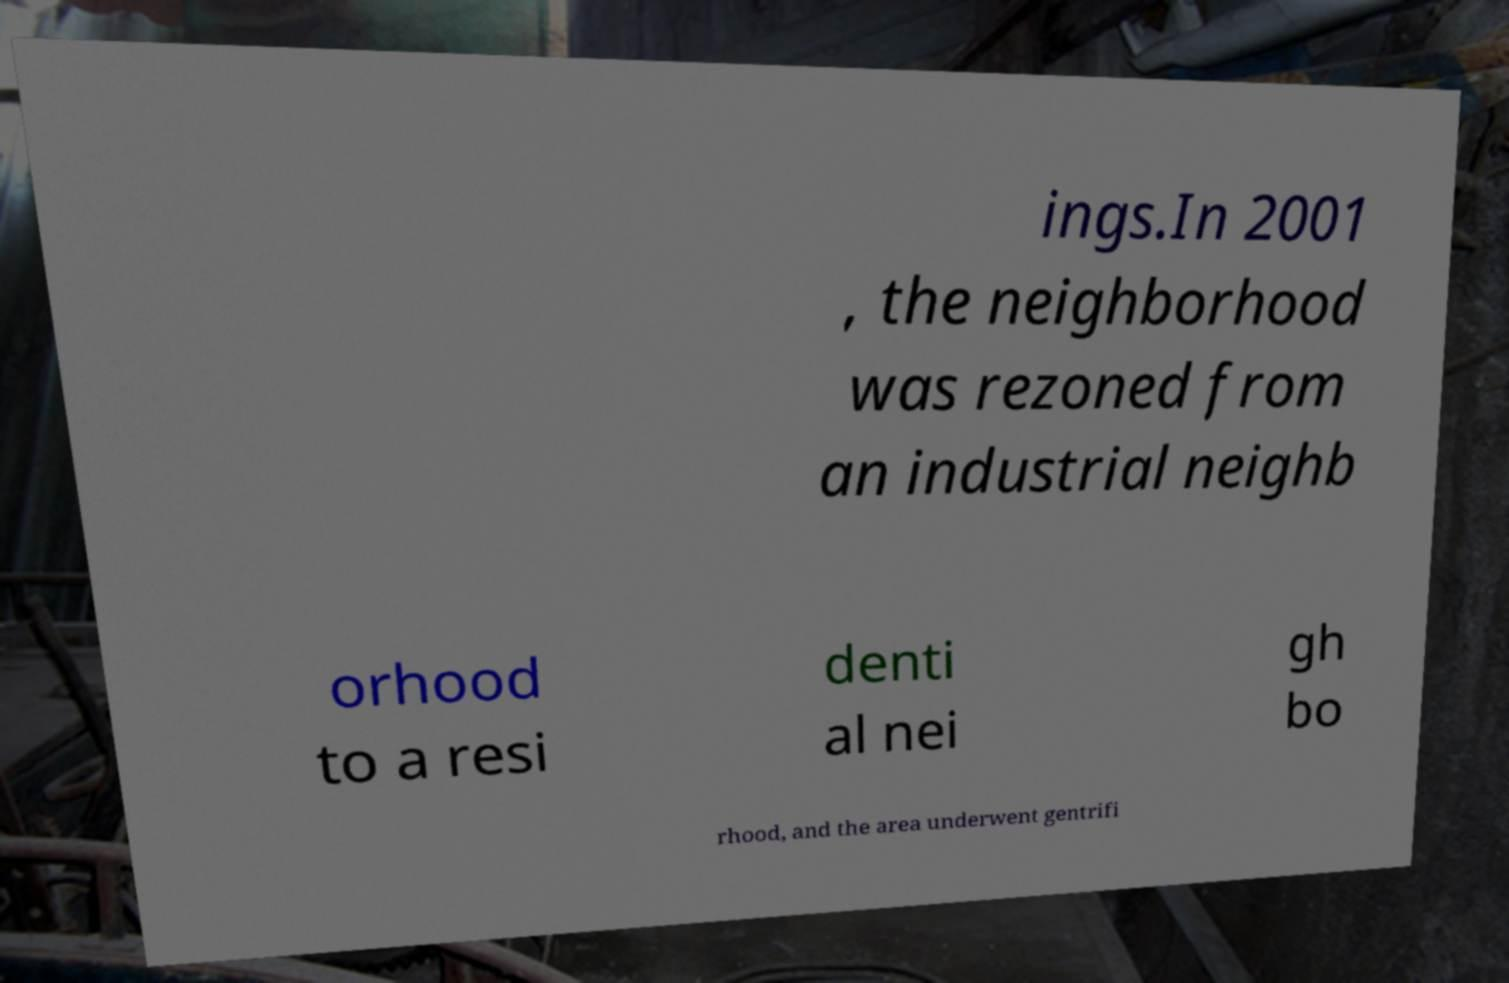Can you accurately transcribe the text from the provided image for me? ings.In 2001 , the neighborhood was rezoned from an industrial neighb orhood to a resi denti al nei gh bo rhood, and the area underwent gentrifi 